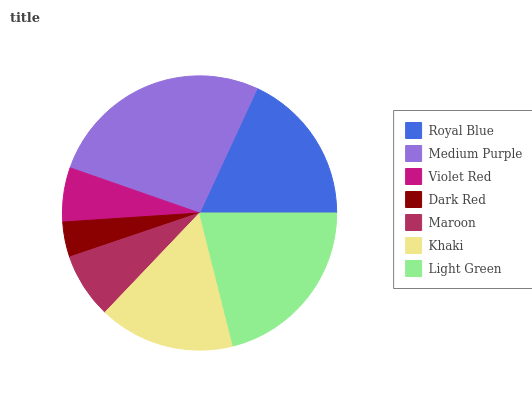Is Dark Red the minimum?
Answer yes or no. Yes. Is Medium Purple the maximum?
Answer yes or no. Yes. Is Violet Red the minimum?
Answer yes or no. No. Is Violet Red the maximum?
Answer yes or no. No. Is Medium Purple greater than Violet Red?
Answer yes or no. Yes. Is Violet Red less than Medium Purple?
Answer yes or no. Yes. Is Violet Red greater than Medium Purple?
Answer yes or no. No. Is Medium Purple less than Violet Red?
Answer yes or no. No. Is Khaki the high median?
Answer yes or no. Yes. Is Khaki the low median?
Answer yes or no. Yes. Is Violet Red the high median?
Answer yes or no. No. Is Dark Red the low median?
Answer yes or no. No. 